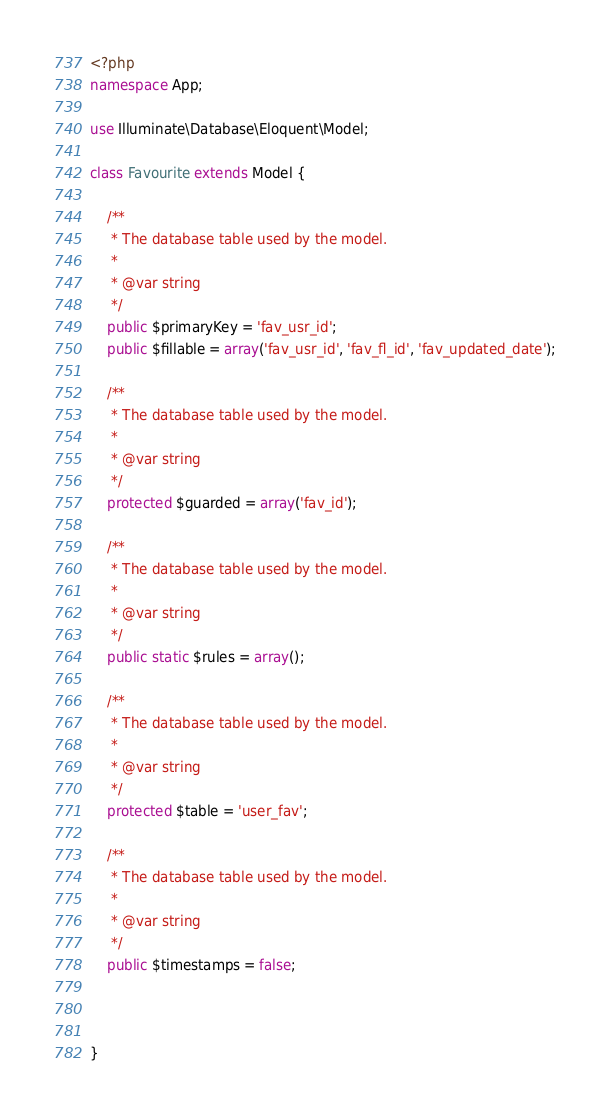Convert code to text. <code><loc_0><loc_0><loc_500><loc_500><_PHP_><?php
namespace App;

use Illuminate\Database\Eloquent\Model;

class Favourite extends Model {

    /**
     * The database table used by the model.
     *
     * @var string
     */
    public $primaryKey = 'fav_usr_id';
    public $fillable = array('fav_usr_id', 'fav_fl_id', 'fav_updated_date');

    /**
     * The database table used by the model.
     *
     * @var string
     */
    protected $guarded = array('fav_id');

    /**
     * The database table used by the model.
     *
     * @var string
     */
    public static $rules = array();

    /**
     * The database table used by the model.
     *
     * @var string
     */
    protected $table = 'user_fav';

    /**
     * The database table used by the model.
     *
     * @var string
     */
    public $timestamps = false;



}
</code> 